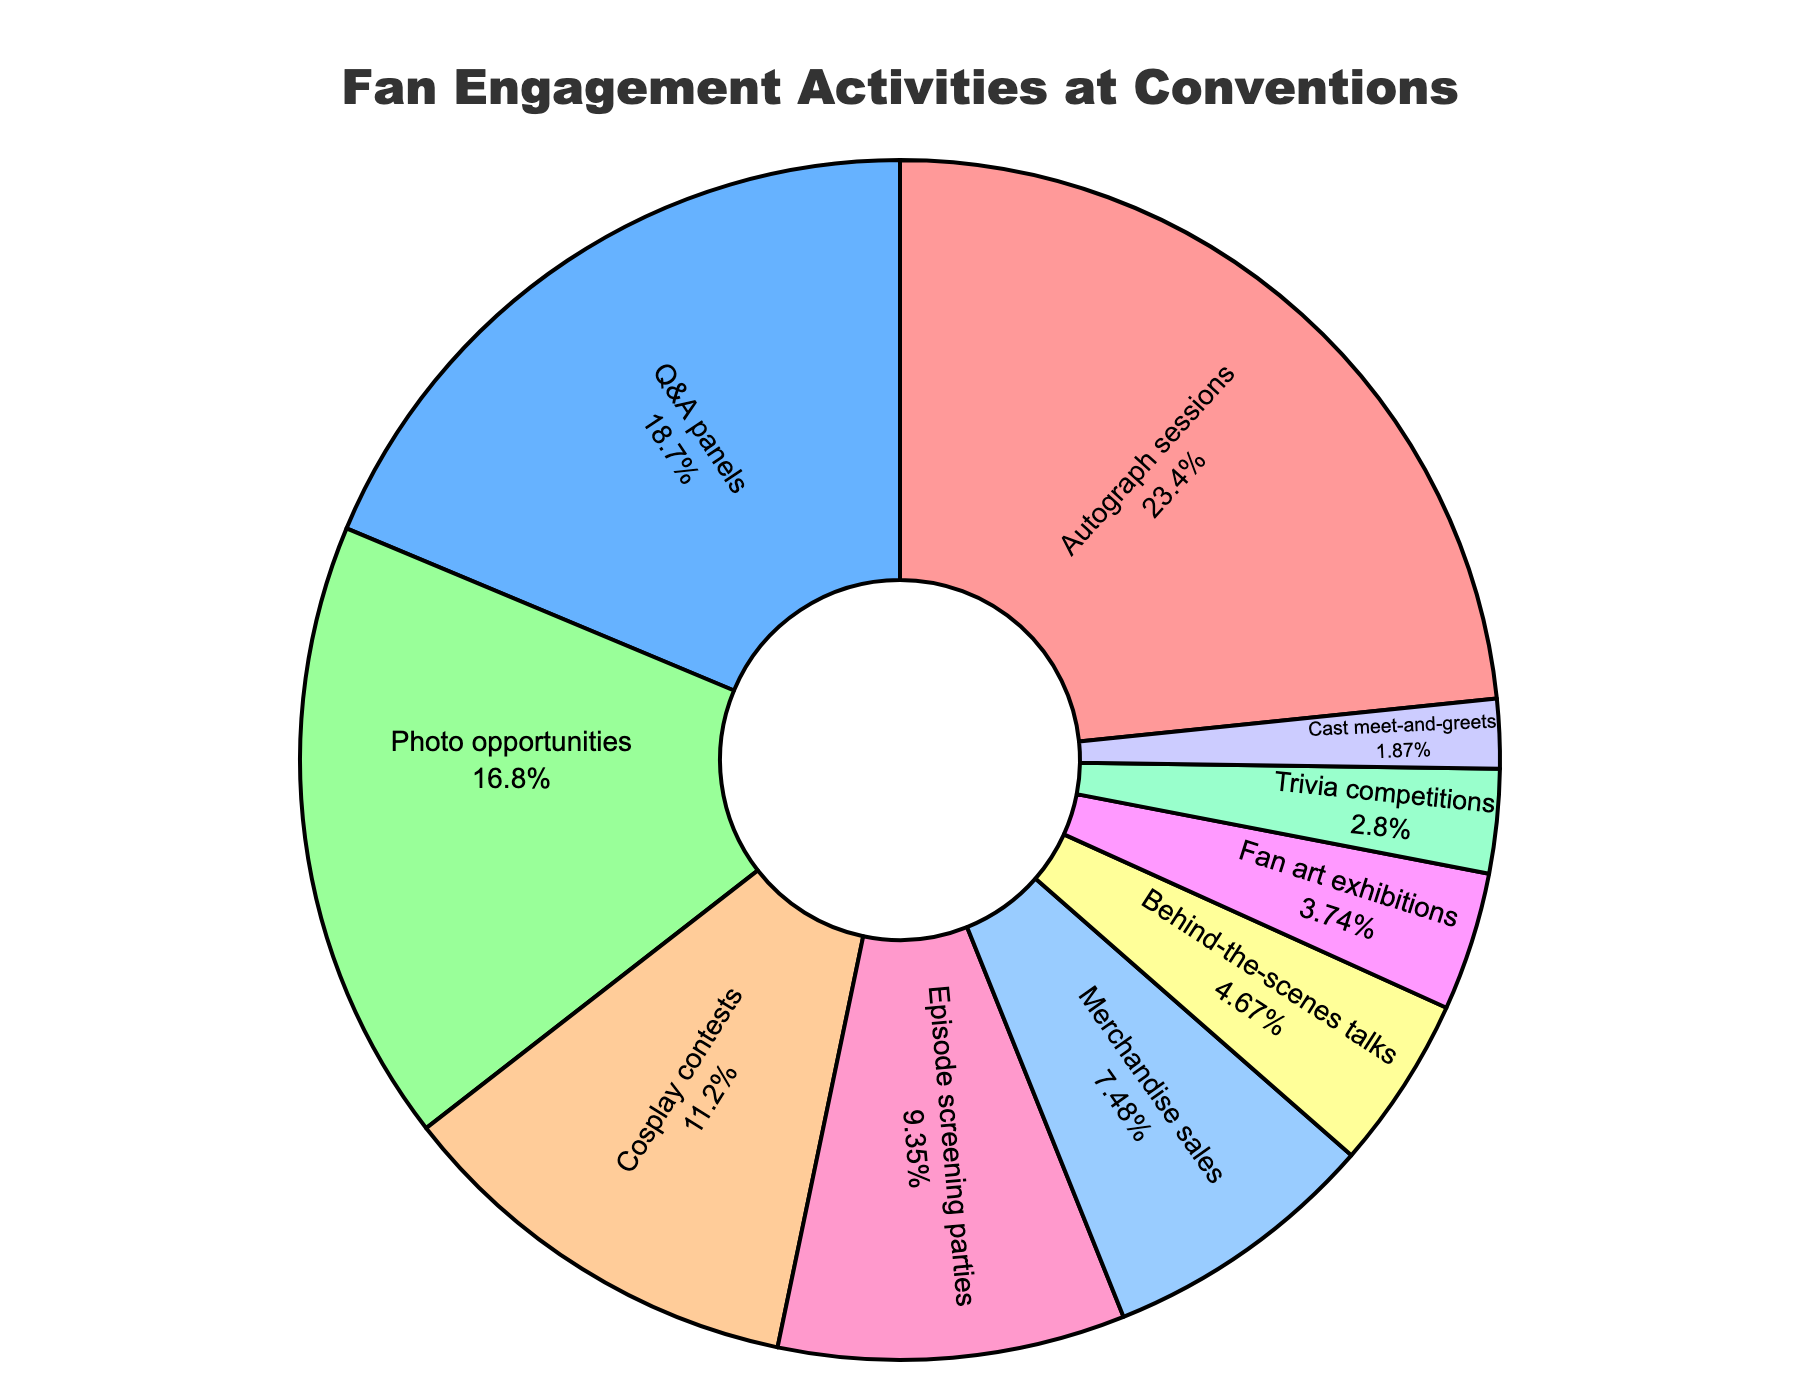Which activity has the highest percentage of fan engagement? The activity with the highest percentage is visually the largest segment in the pie chart. This segment is "Autograph sessions" with 25%.
Answer: Autograph sessions Which activities combined make up more than 50% of the fan engagement? You need to sum the percentages of the largest segments until the total exceeds 50%. Autograph sessions (25%) + Q&A panels (20%) = 45%, and adding Photo opportunities (18%) gives a sum of 63%.
Answer: Autograph sessions, Q&A panels, and Photo opportunities What's the combined percentage of Cosplay contests and Episode screening parties? Adding the percentages for Cosplay contests (12%) and Episode screening parties (10%) gives the combined value: 12% + 10% = 22%.
Answer: 22% Which activity has a percentage closest to 10%? Look for the segment with a percentage value closest to 10%. In this case, "Episode screening parties" matches exactly with 10%.
Answer: Episode screening parties What is the difference in percentage between Merchandise sales and Behind-the-scenes talks? Subtract the percentage of Behind-the-scenes talks (5%) from that of Merchandise sales (8%): 8% - 5% = 3%.
Answer: 3% Which activity occupies the smallest segment in the pie chart? Identify the segment which is visually the smallest part of the pie chart. This is "Cast meet-and-greets" with 2%.
Answer: Cast meet-and-greets Are there more activities with percentages above or below 10%? Count the number of activities with percentages greater than 10% and those below. There are 4 activities above 10%: Autograph sessions, Q&A panels, Photo opportunities, Cosplay contests, and 6 activities below 10%.
Answer: Below 10% Do Cosplay contests and Trivia competitions together outnumber Q&A panels? Add the percentages of Cosplay contests (12%) and Trivia competitions (3%) and compare to Q&A panels (20%): 12% + 3% = 15%, which is less than 20%.
Answer: No What is the color of the segment representing Q&A panels? Observe the visual color given to Q&A panels in the pie chart. According to the defined color scheme, Q&A panels have a blue color.
Answer: Blue 